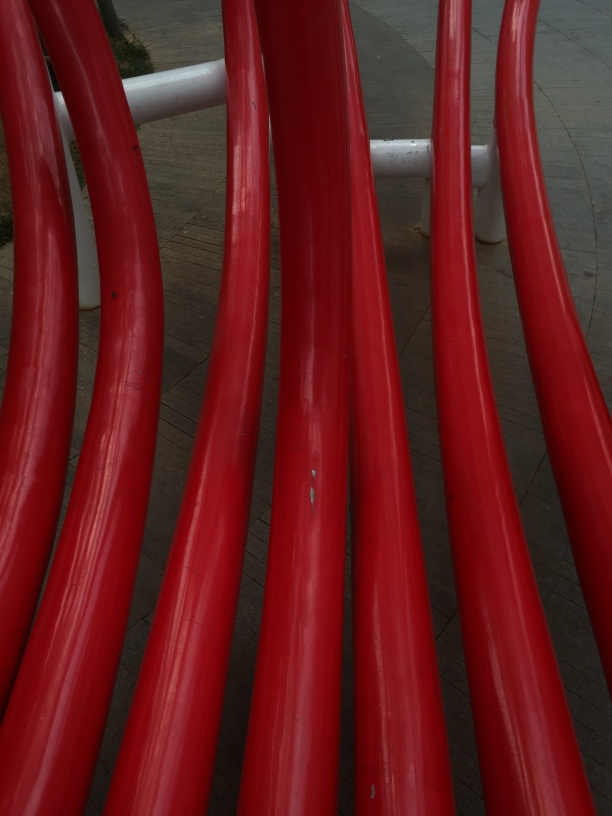What can you tell about the design and purpose of these red structures? The red structures in the image seem to be part of a larger installation, possibly serving as a decorative element or as part of a playground. Their smooth, curved design indicates careful consideration of form, potentially inviting interaction or simply providing visual interest in the space. Could the red color of these structures have a specific significance? While the specific significance of the red color can vary, it often symbolizes passion, vitality, or excitement. In public installations, a bright color like red is also used to draw attention and create a vibrant atmosphere. It's possibly chosen to contrast with the surroundings and make the installation stand out. 